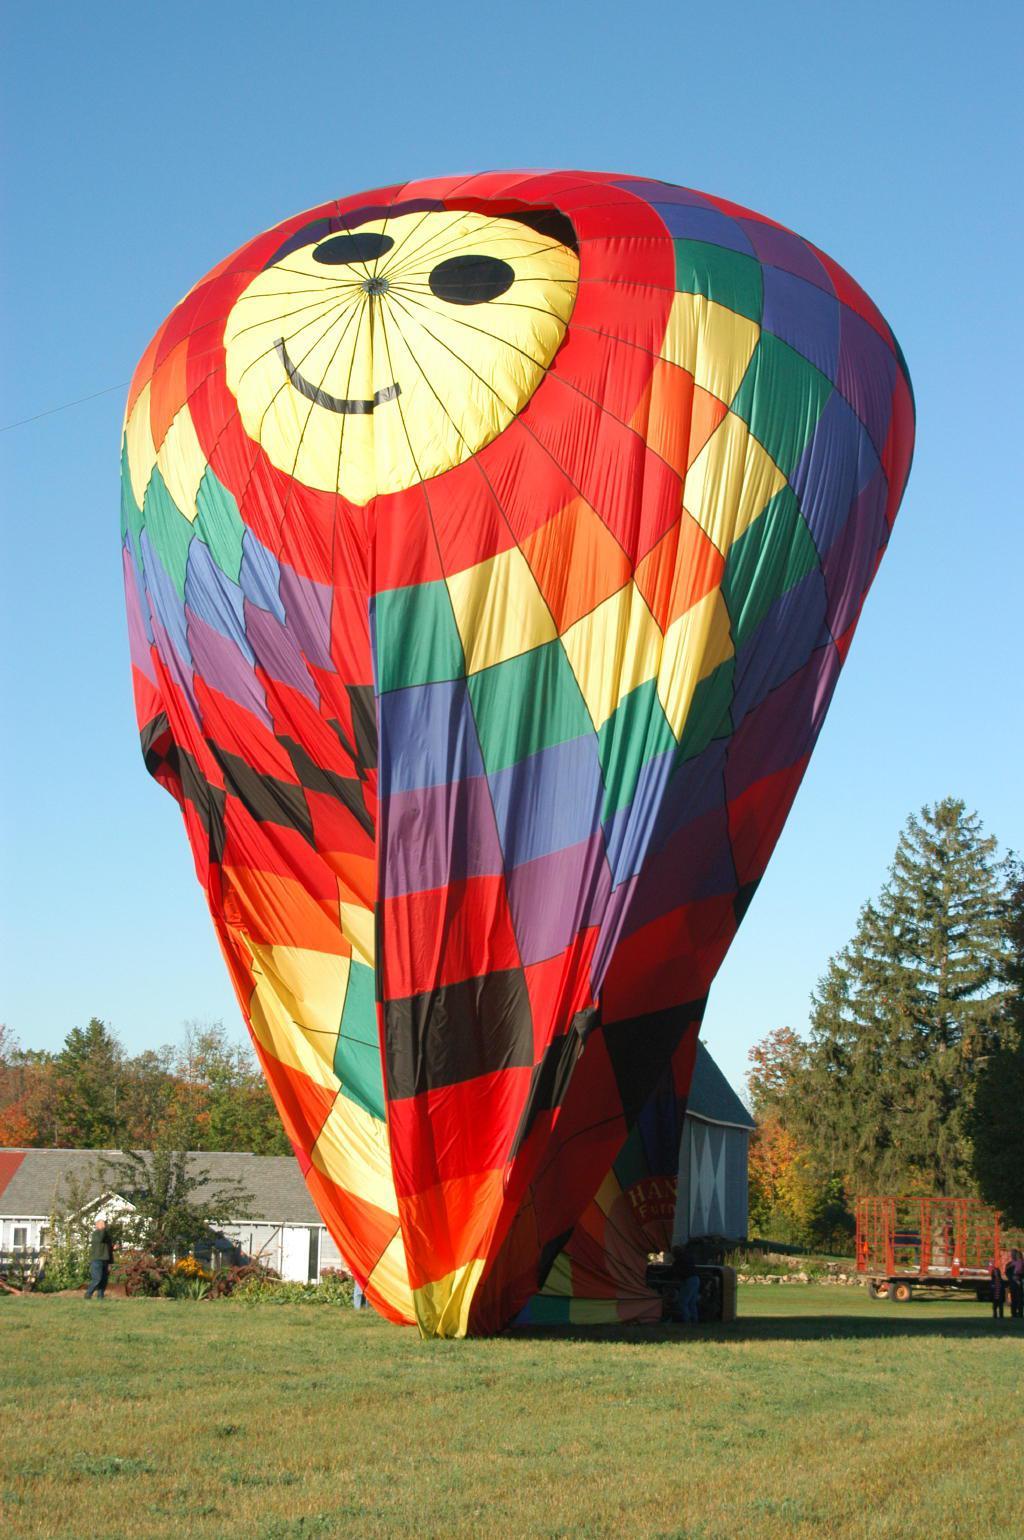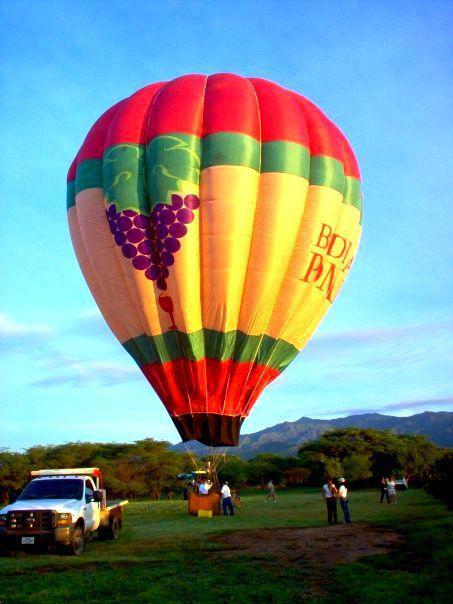The first image is the image on the left, the second image is the image on the right. Given the left and right images, does the statement "One of the balloons has a face depicted on it." hold true? Answer yes or no. Yes. 